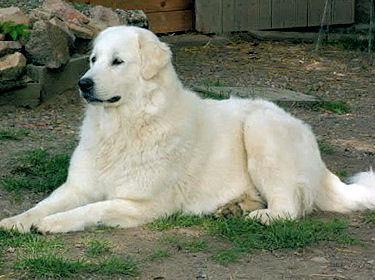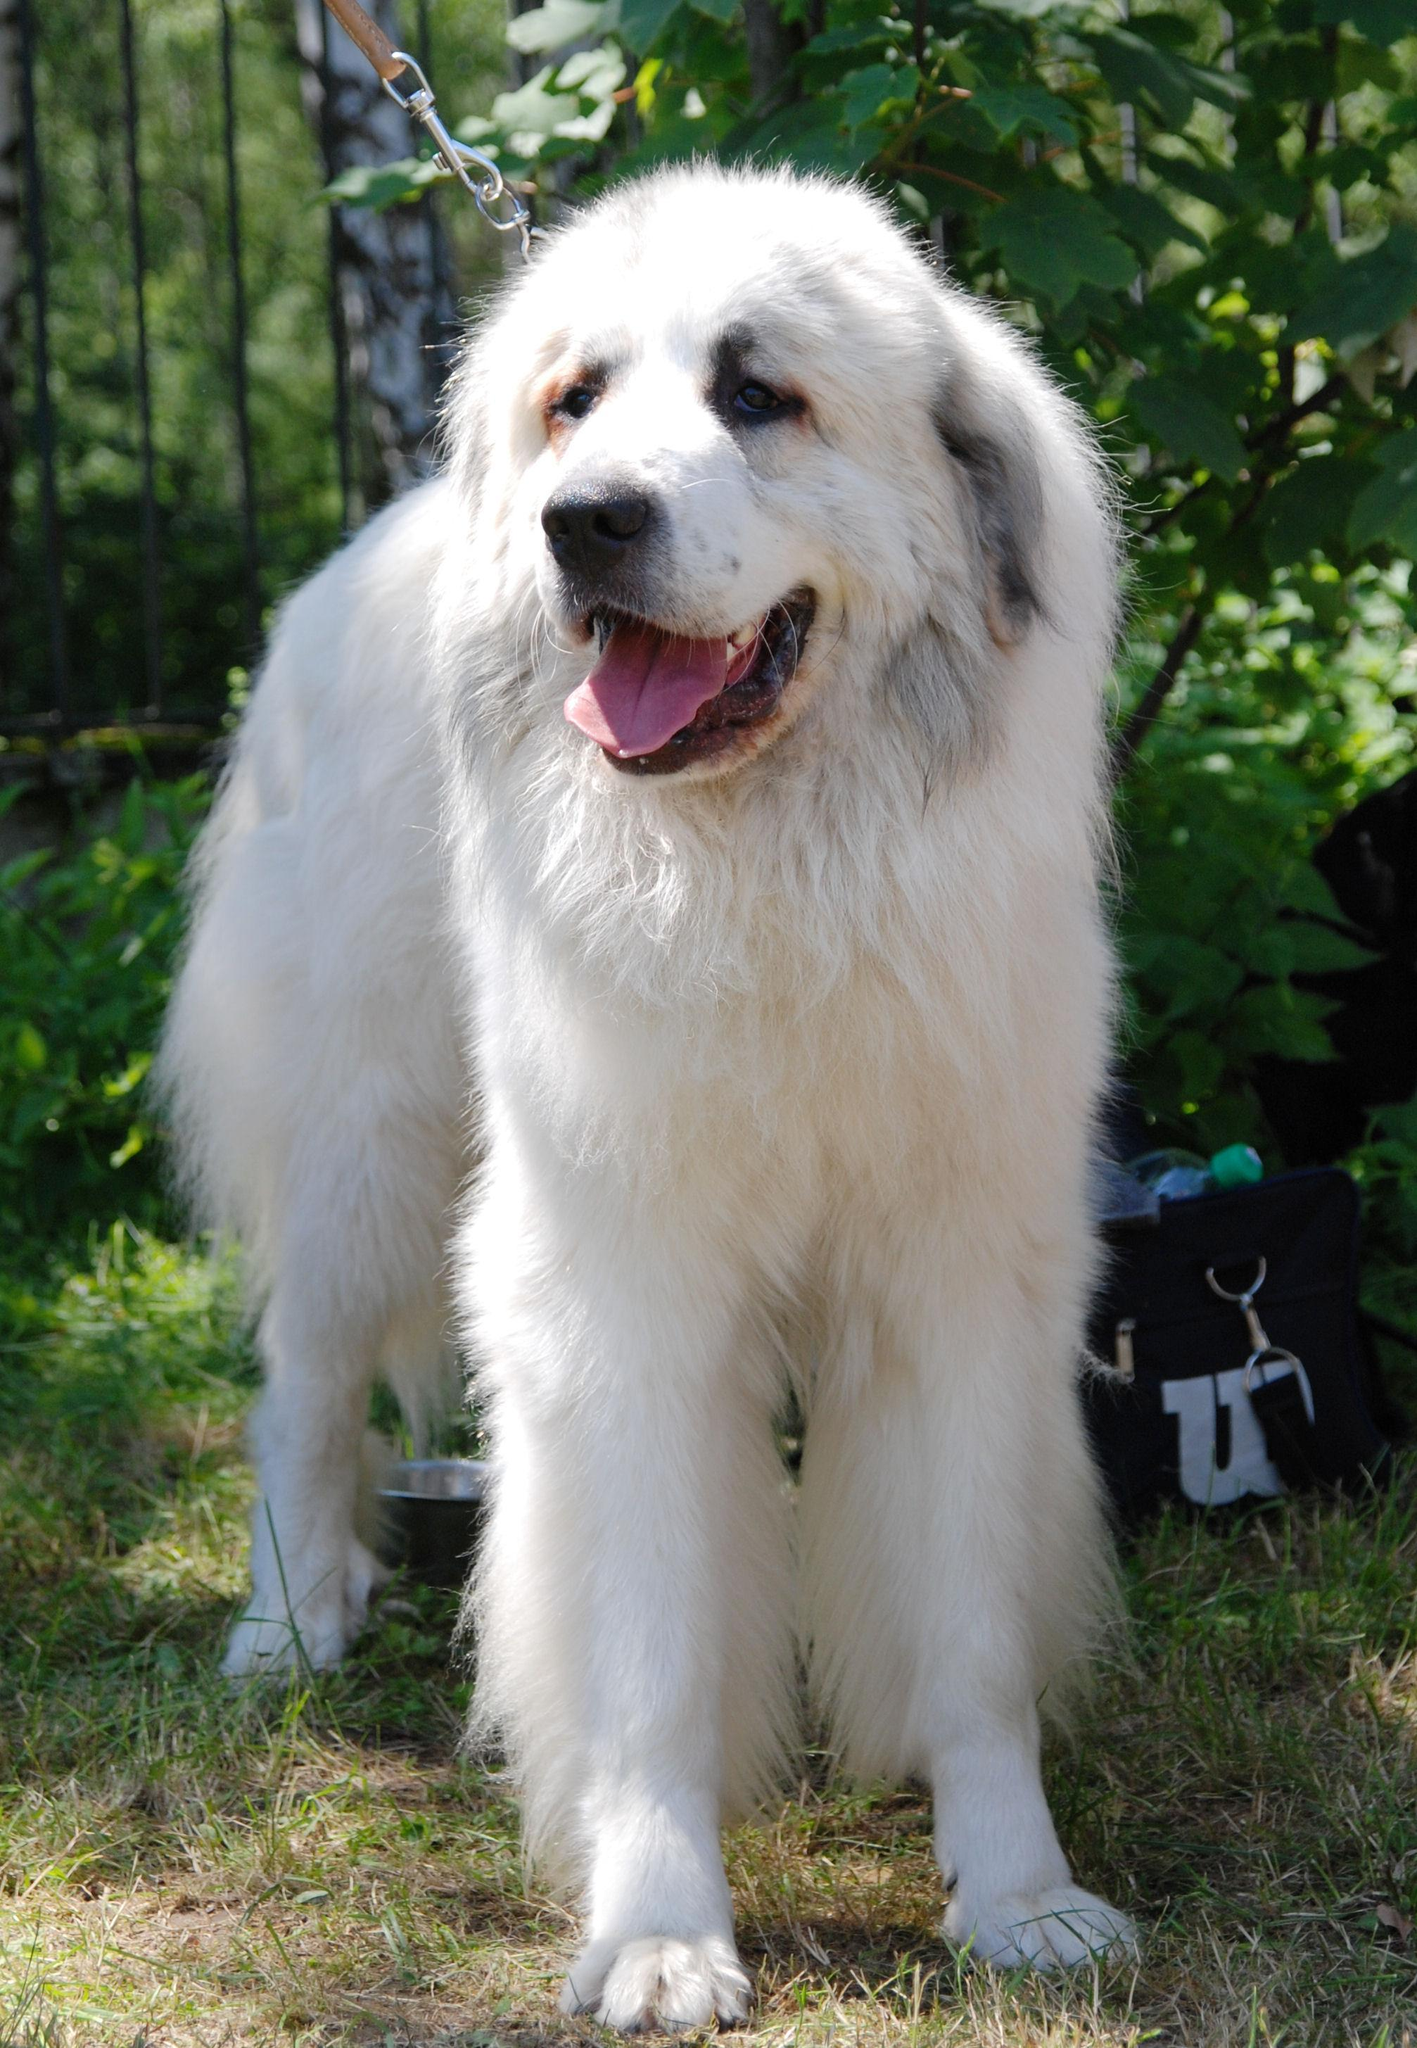The first image is the image on the left, the second image is the image on the right. Examine the images to the left and right. Is the description "A full sized dog is sitting with its legs extended on the ground" accurate? Answer yes or no. Yes. 